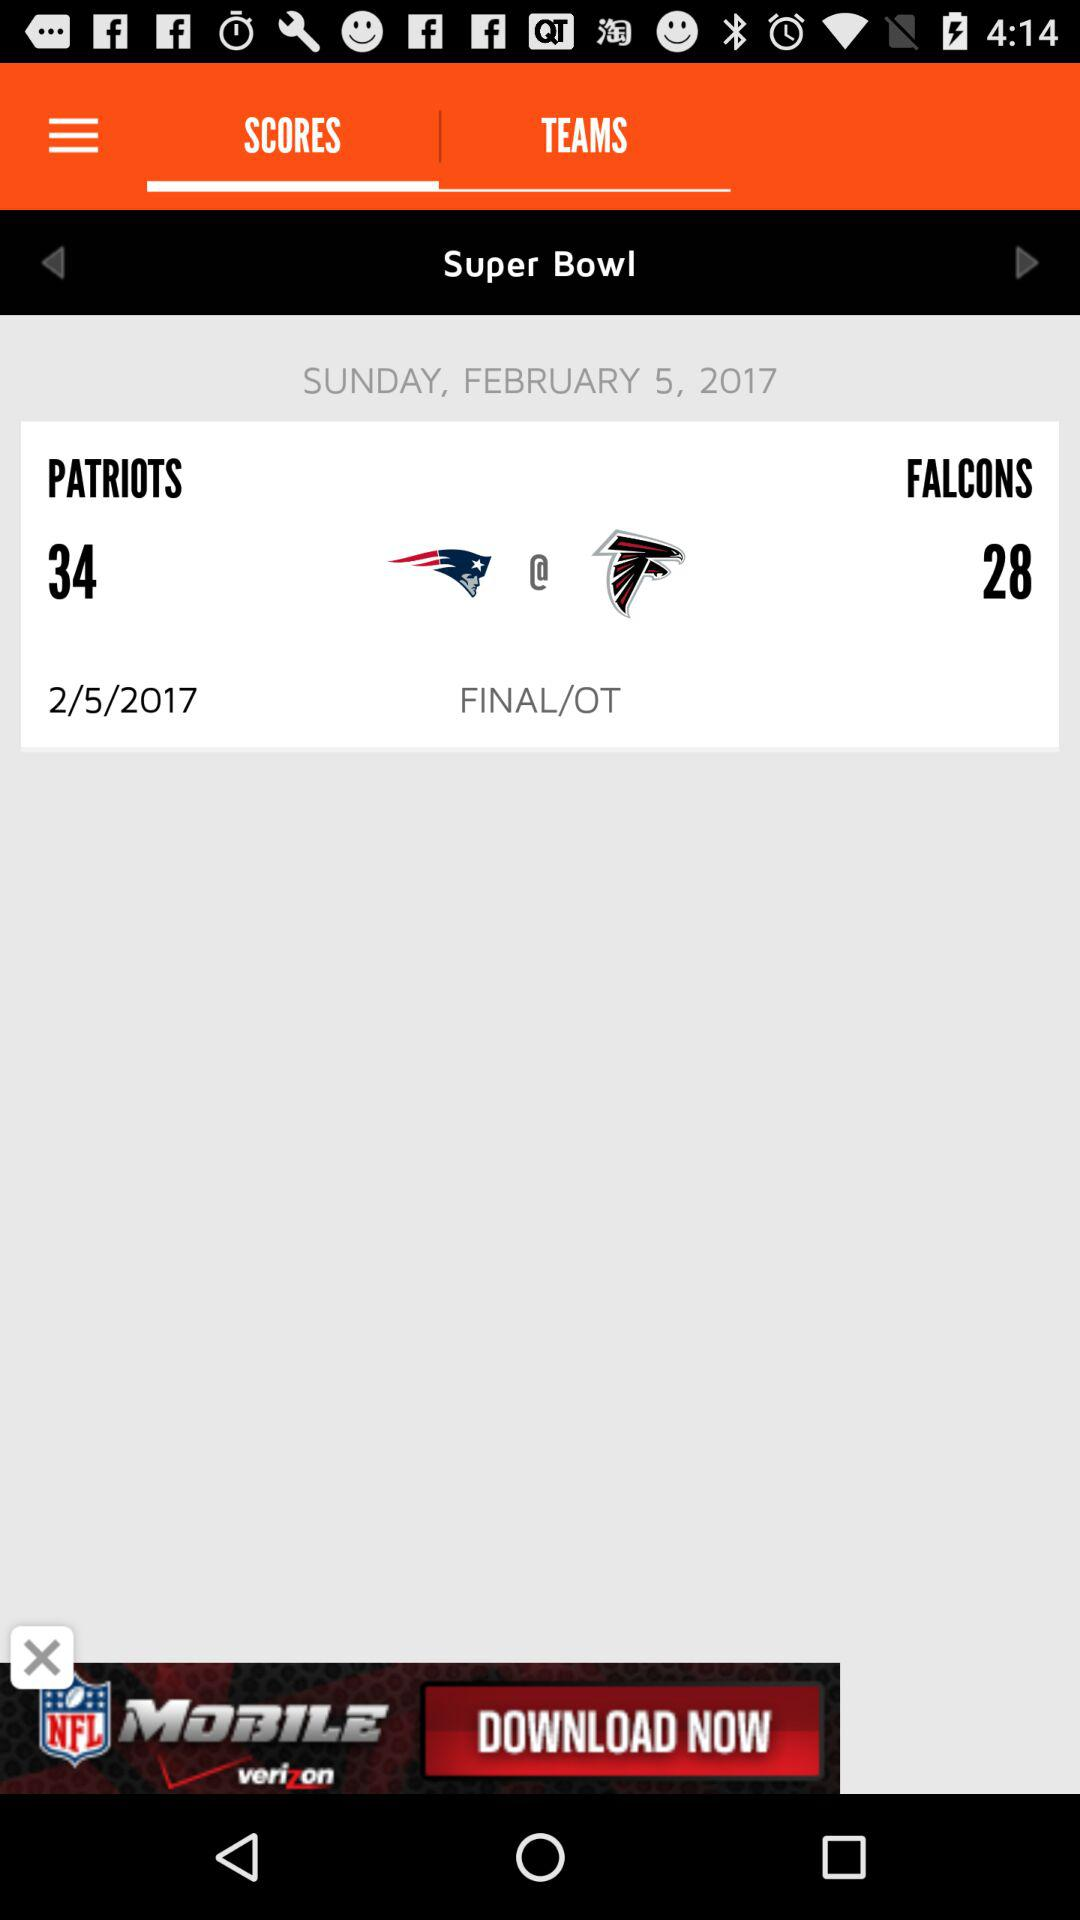How many more points do the Patriots have than the Falcons?
Answer the question using a single word or phrase. 6 